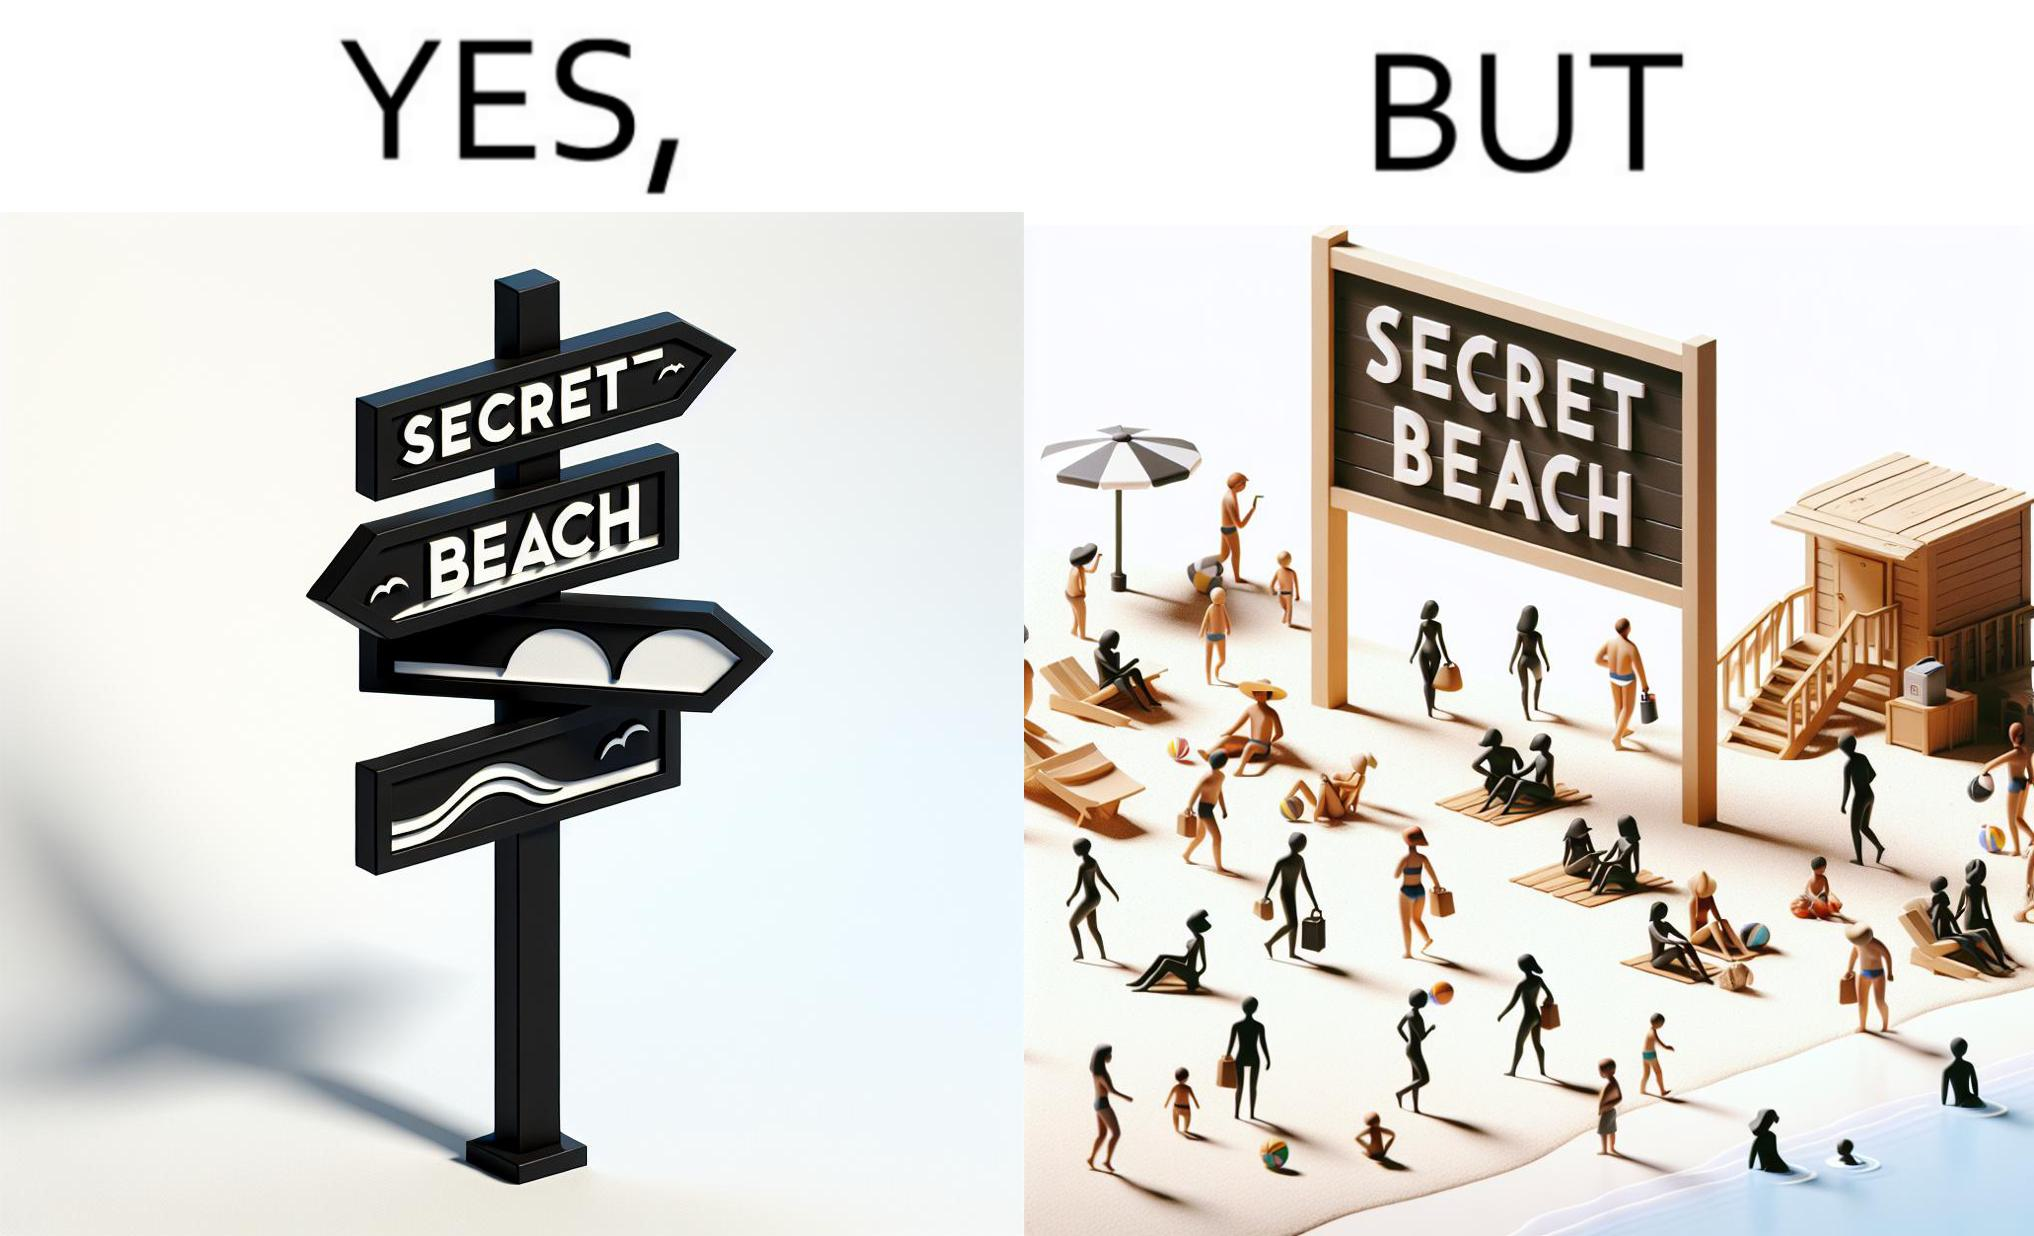Why is this image considered satirical? The image is ironical, as people can be seen in the beach, and is clearly not a secret, while the board at the entrance has "Secret Beach" written on it. 